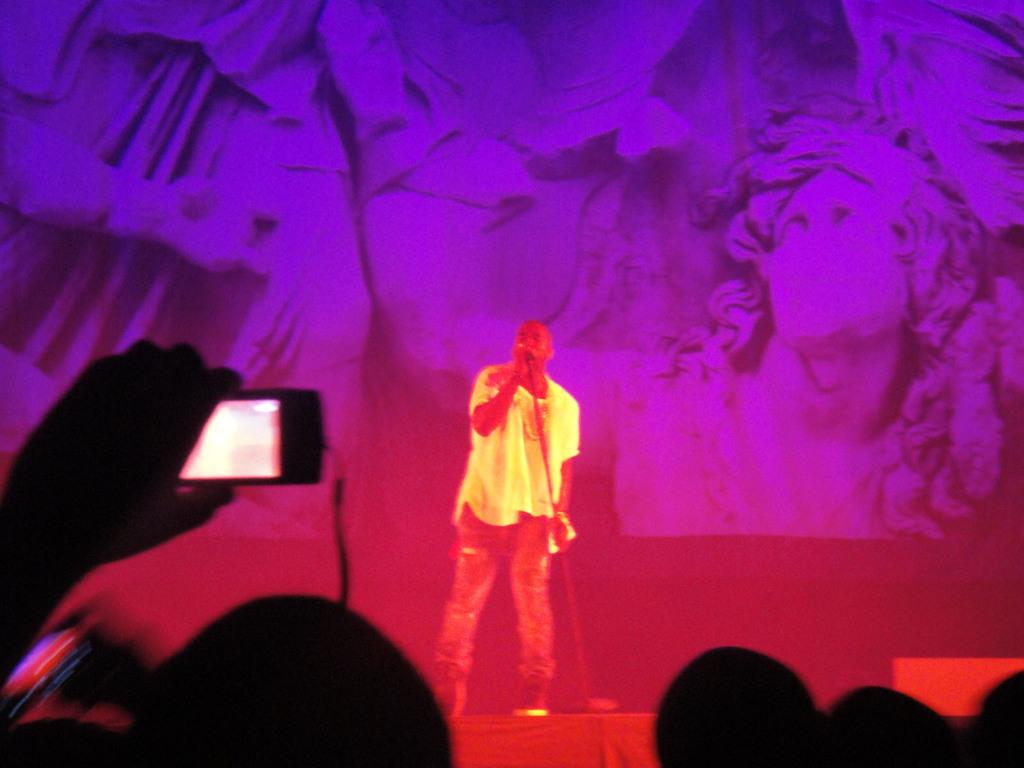What is the person on the left side of the image holding? The person on the left side of the image is holding a camera. What is the person in the middle of the image doing? The person in the middle of the image is singing. What can be seen in the background of the image? There appears to be a screen in the background of the image. How do we know that the image has been edited? The fact states that the image is edited. What type of metal is the rain falling on in the image? There is no metal or rain present in the image. What is the rod used for in the image? There is no rod present in the image. 